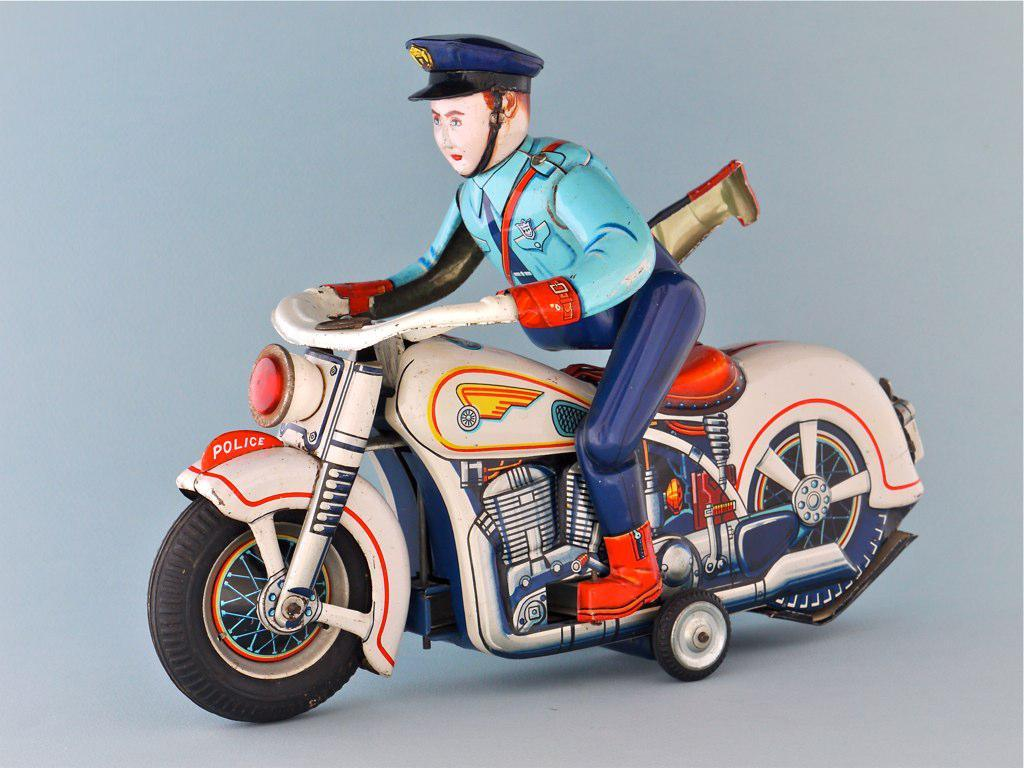What is the main subject in the center of the image? There is a toy of a policeman in the center of the image. What is the toy policeman doing in the image? The toy policeman is on a bike. What is the color of the surface on which the image is placed? The image has a white surface. What type of jar is visible in the image? There is no jar present in the image. Can you describe the burst of colors in the image? There is no burst of colors in the image; it features a toy policeman on a bike against a white surface. 